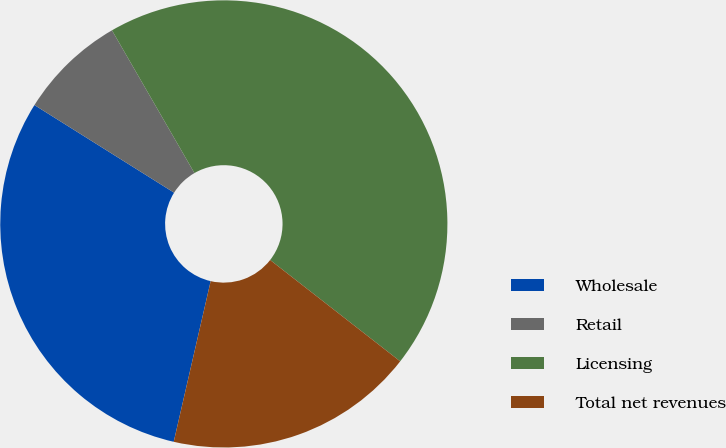Convert chart. <chart><loc_0><loc_0><loc_500><loc_500><pie_chart><fcel>Wholesale<fcel>Retail<fcel>Licensing<fcel>Total net revenues<nl><fcel>30.32%<fcel>7.74%<fcel>43.87%<fcel>18.06%<nl></chart> 